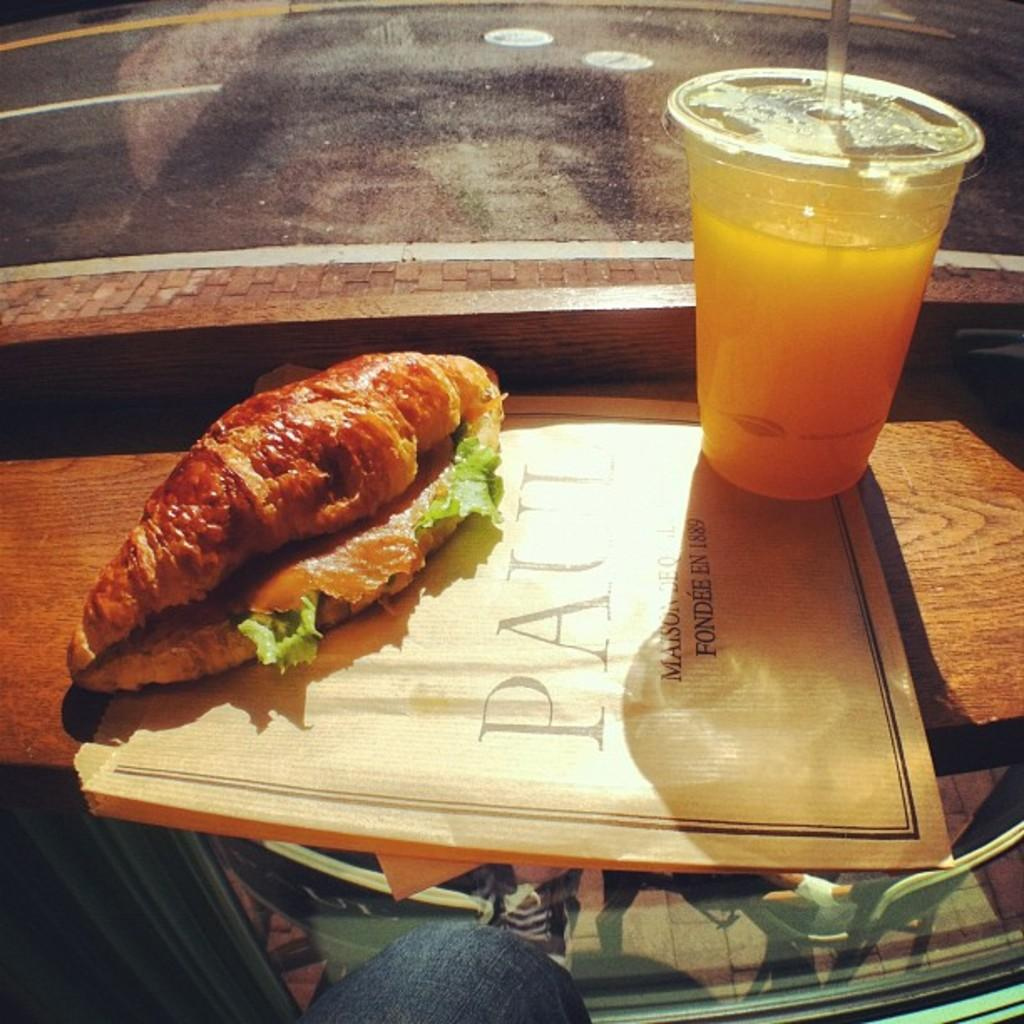What is the food item on the table in the image? Unfortunately, the provided facts do not specify the type of food item on the table. What can be seen on the right side of the table? There is a glass with liquid in it on the right side of the table. How does the wealth of the town affect the food item on the table? The provided facts do not mention anything about wealth or the town, so it is impossible to determine any connection between them and the food item on the table. What type of ornament is present on the glass with liquid in it? The provided facts do not mention any ornament on the glass with liquid in it. 